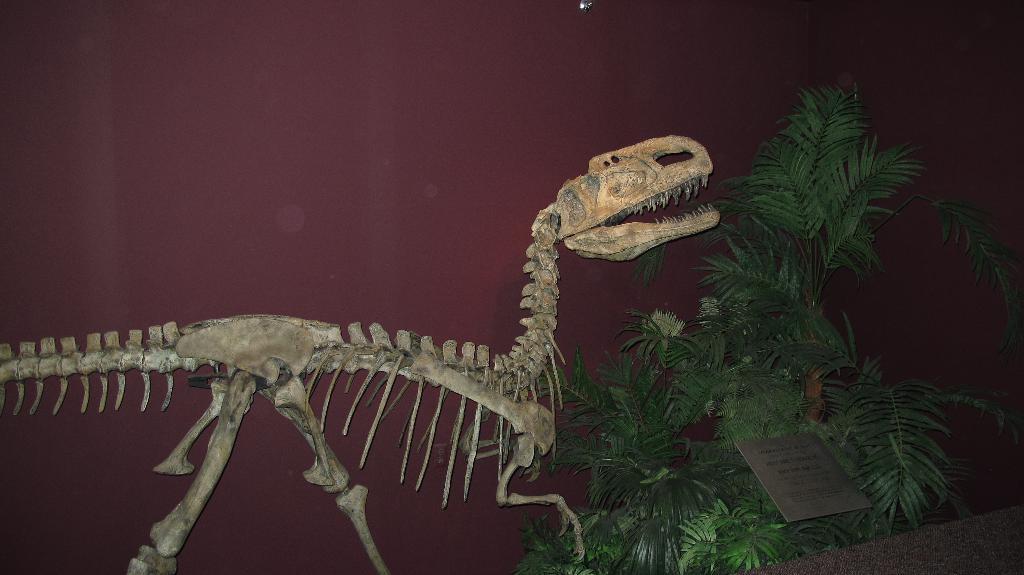Could you give a brief overview of what you see in this image? In this picture we can see a dinosaur skeleton. On the right side of the skeleton, there is a board and a tree. Behind the skeleton, it looks like a wall. 